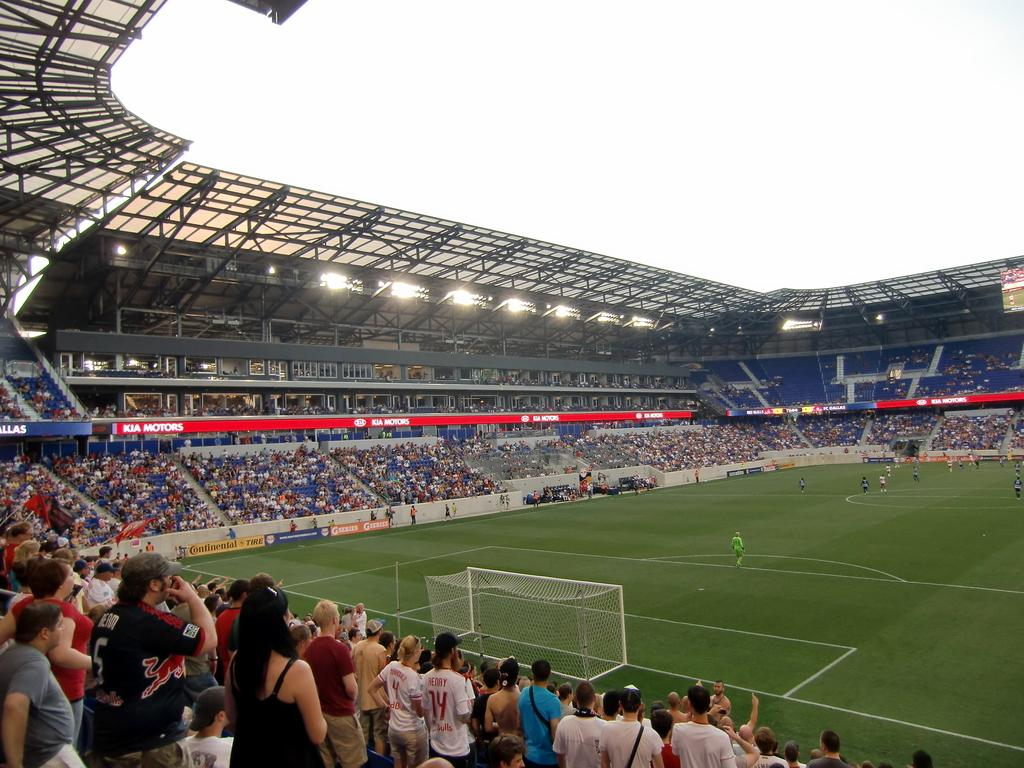<image>
Render a clear and concise summary of the photo. Man wearing a white number 14 jersey cheering in the crowd. 